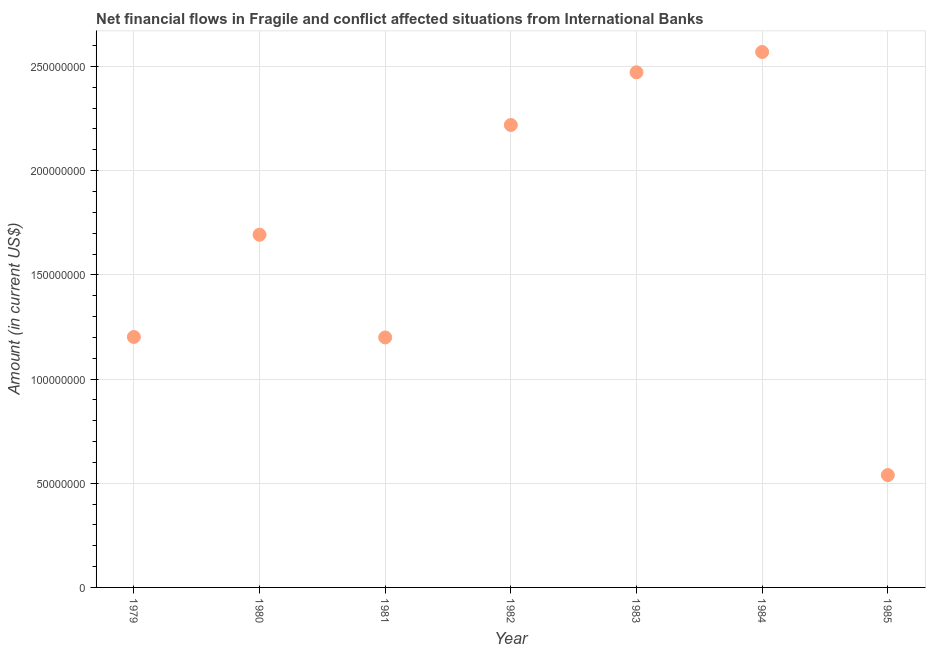What is the net financial flows from ibrd in 1981?
Offer a terse response. 1.20e+08. Across all years, what is the maximum net financial flows from ibrd?
Provide a short and direct response. 2.57e+08. Across all years, what is the minimum net financial flows from ibrd?
Keep it short and to the point. 5.39e+07. In which year was the net financial flows from ibrd maximum?
Your answer should be very brief. 1984. What is the sum of the net financial flows from ibrd?
Offer a very short reply. 1.19e+09. What is the difference between the net financial flows from ibrd in 1980 and 1982?
Provide a succinct answer. -5.27e+07. What is the average net financial flows from ibrd per year?
Offer a very short reply. 1.70e+08. What is the median net financial flows from ibrd?
Keep it short and to the point. 1.69e+08. In how many years, is the net financial flows from ibrd greater than 90000000 US$?
Provide a succinct answer. 6. What is the ratio of the net financial flows from ibrd in 1981 to that in 1985?
Make the answer very short. 2.22. Is the net financial flows from ibrd in 1980 less than that in 1982?
Make the answer very short. Yes. What is the difference between the highest and the second highest net financial flows from ibrd?
Your answer should be compact. 9.75e+06. Is the sum of the net financial flows from ibrd in 1980 and 1981 greater than the maximum net financial flows from ibrd across all years?
Your answer should be compact. Yes. What is the difference between the highest and the lowest net financial flows from ibrd?
Your response must be concise. 2.03e+08. In how many years, is the net financial flows from ibrd greater than the average net financial flows from ibrd taken over all years?
Keep it short and to the point. 3. Does the graph contain grids?
Your answer should be compact. Yes. What is the title of the graph?
Give a very brief answer. Net financial flows in Fragile and conflict affected situations from International Banks. What is the Amount (in current US$) in 1979?
Make the answer very short. 1.20e+08. What is the Amount (in current US$) in 1980?
Provide a short and direct response. 1.69e+08. What is the Amount (in current US$) in 1981?
Ensure brevity in your answer.  1.20e+08. What is the Amount (in current US$) in 1982?
Give a very brief answer. 2.22e+08. What is the Amount (in current US$) in 1983?
Ensure brevity in your answer.  2.47e+08. What is the Amount (in current US$) in 1984?
Keep it short and to the point. 2.57e+08. What is the Amount (in current US$) in 1985?
Offer a terse response. 5.39e+07. What is the difference between the Amount (in current US$) in 1979 and 1980?
Provide a short and direct response. -4.91e+07. What is the difference between the Amount (in current US$) in 1979 and 1981?
Provide a short and direct response. 2.24e+05. What is the difference between the Amount (in current US$) in 1979 and 1982?
Offer a very short reply. -1.02e+08. What is the difference between the Amount (in current US$) in 1979 and 1983?
Offer a terse response. -1.27e+08. What is the difference between the Amount (in current US$) in 1979 and 1984?
Make the answer very short. -1.37e+08. What is the difference between the Amount (in current US$) in 1979 and 1985?
Give a very brief answer. 6.63e+07. What is the difference between the Amount (in current US$) in 1980 and 1981?
Make the answer very short. 4.93e+07. What is the difference between the Amount (in current US$) in 1980 and 1982?
Your answer should be compact. -5.27e+07. What is the difference between the Amount (in current US$) in 1980 and 1983?
Your response must be concise. -7.79e+07. What is the difference between the Amount (in current US$) in 1980 and 1984?
Provide a succinct answer. -8.77e+07. What is the difference between the Amount (in current US$) in 1980 and 1985?
Provide a short and direct response. 1.15e+08. What is the difference between the Amount (in current US$) in 1981 and 1982?
Your response must be concise. -1.02e+08. What is the difference between the Amount (in current US$) in 1981 and 1983?
Make the answer very short. -1.27e+08. What is the difference between the Amount (in current US$) in 1981 and 1984?
Keep it short and to the point. -1.37e+08. What is the difference between the Amount (in current US$) in 1981 and 1985?
Ensure brevity in your answer.  6.60e+07. What is the difference between the Amount (in current US$) in 1982 and 1983?
Make the answer very short. -2.53e+07. What is the difference between the Amount (in current US$) in 1982 and 1984?
Your response must be concise. -3.50e+07. What is the difference between the Amount (in current US$) in 1982 and 1985?
Your answer should be very brief. 1.68e+08. What is the difference between the Amount (in current US$) in 1983 and 1984?
Ensure brevity in your answer.  -9.75e+06. What is the difference between the Amount (in current US$) in 1983 and 1985?
Offer a very short reply. 1.93e+08. What is the difference between the Amount (in current US$) in 1984 and 1985?
Keep it short and to the point. 2.03e+08. What is the ratio of the Amount (in current US$) in 1979 to that in 1980?
Keep it short and to the point. 0.71. What is the ratio of the Amount (in current US$) in 1979 to that in 1981?
Your response must be concise. 1. What is the ratio of the Amount (in current US$) in 1979 to that in 1982?
Provide a succinct answer. 0.54. What is the ratio of the Amount (in current US$) in 1979 to that in 1983?
Keep it short and to the point. 0.49. What is the ratio of the Amount (in current US$) in 1979 to that in 1984?
Make the answer very short. 0.47. What is the ratio of the Amount (in current US$) in 1979 to that in 1985?
Your answer should be compact. 2.23. What is the ratio of the Amount (in current US$) in 1980 to that in 1981?
Make the answer very short. 1.41. What is the ratio of the Amount (in current US$) in 1980 to that in 1982?
Give a very brief answer. 0.76. What is the ratio of the Amount (in current US$) in 1980 to that in 1983?
Keep it short and to the point. 0.69. What is the ratio of the Amount (in current US$) in 1980 to that in 1984?
Your answer should be compact. 0.66. What is the ratio of the Amount (in current US$) in 1980 to that in 1985?
Your response must be concise. 3.14. What is the ratio of the Amount (in current US$) in 1981 to that in 1982?
Make the answer very short. 0.54. What is the ratio of the Amount (in current US$) in 1981 to that in 1983?
Your response must be concise. 0.48. What is the ratio of the Amount (in current US$) in 1981 to that in 1984?
Offer a terse response. 0.47. What is the ratio of the Amount (in current US$) in 1981 to that in 1985?
Your response must be concise. 2.23. What is the ratio of the Amount (in current US$) in 1982 to that in 1983?
Keep it short and to the point. 0.9. What is the ratio of the Amount (in current US$) in 1982 to that in 1984?
Make the answer very short. 0.86. What is the ratio of the Amount (in current US$) in 1982 to that in 1985?
Your answer should be very brief. 4.12. What is the ratio of the Amount (in current US$) in 1983 to that in 1984?
Offer a terse response. 0.96. What is the ratio of the Amount (in current US$) in 1983 to that in 1985?
Offer a terse response. 4.58. What is the ratio of the Amount (in current US$) in 1984 to that in 1985?
Your answer should be very brief. 4.77. 